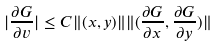<formula> <loc_0><loc_0><loc_500><loc_500>| \frac { \partial G } { \partial v } | \leq C \| ( x , y ) \| \| ( \frac { \partial G } { \partial x } , \frac { \partial G } { \partial y } ) \|</formula> 